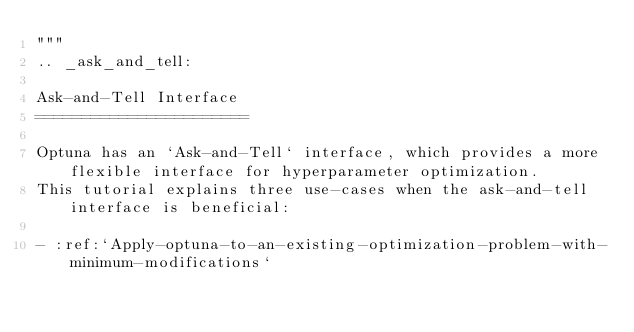Convert code to text. <code><loc_0><loc_0><loc_500><loc_500><_Python_>"""
.. _ask_and_tell:

Ask-and-Tell Interface
=======================

Optuna has an `Ask-and-Tell` interface, which provides a more flexible interface for hyperparameter optimization.
This tutorial explains three use-cases when the ask-and-tell interface is beneficial:

- :ref:`Apply-optuna-to-an-existing-optimization-problem-with-minimum-modifications`</code> 